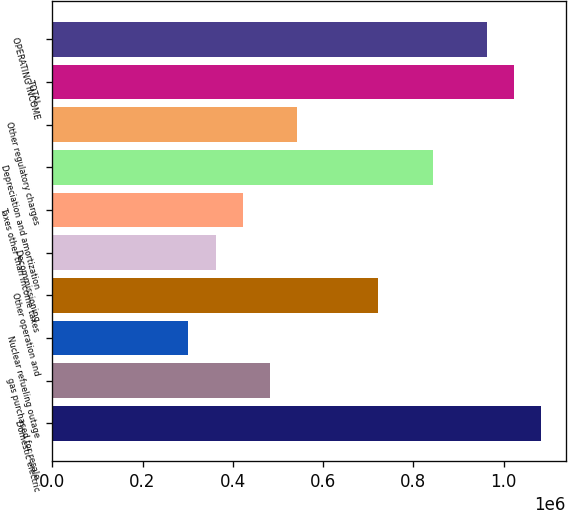Convert chart to OTSL. <chart><loc_0><loc_0><loc_500><loc_500><bar_chart><fcel>Domestic electric<fcel>gas purchased for resale<fcel>Nuclear refueling outage<fcel>Other operation and<fcel>Decommissioning<fcel>Taxes other than income taxes<fcel>Depreciation and amortization<fcel>Other regulatory charges<fcel>TOTAL<fcel>OPERATING INCOME<nl><fcel>1.08381e+06<fcel>482154<fcel>301656<fcel>722818<fcel>361822<fcel>421988<fcel>843150<fcel>542320<fcel>1.02365e+06<fcel>963482<nl></chart> 